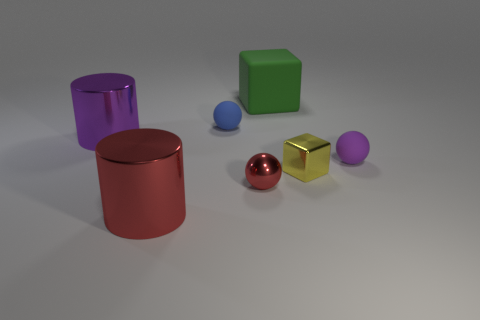Add 1 tiny rubber objects. How many objects exist? 8 Subtract all cylinders. How many objects are left? 5 Subtract all large red objects. Subtract all yellow blocks. How many objects are left? 5 Add 5 large purple metal objects. How many large purple metal objects are left? 6 Add 2 large matte blocks. How many large matte blocks exist? 3 Subtract 0 gray spheres. How many objects are left? 7 